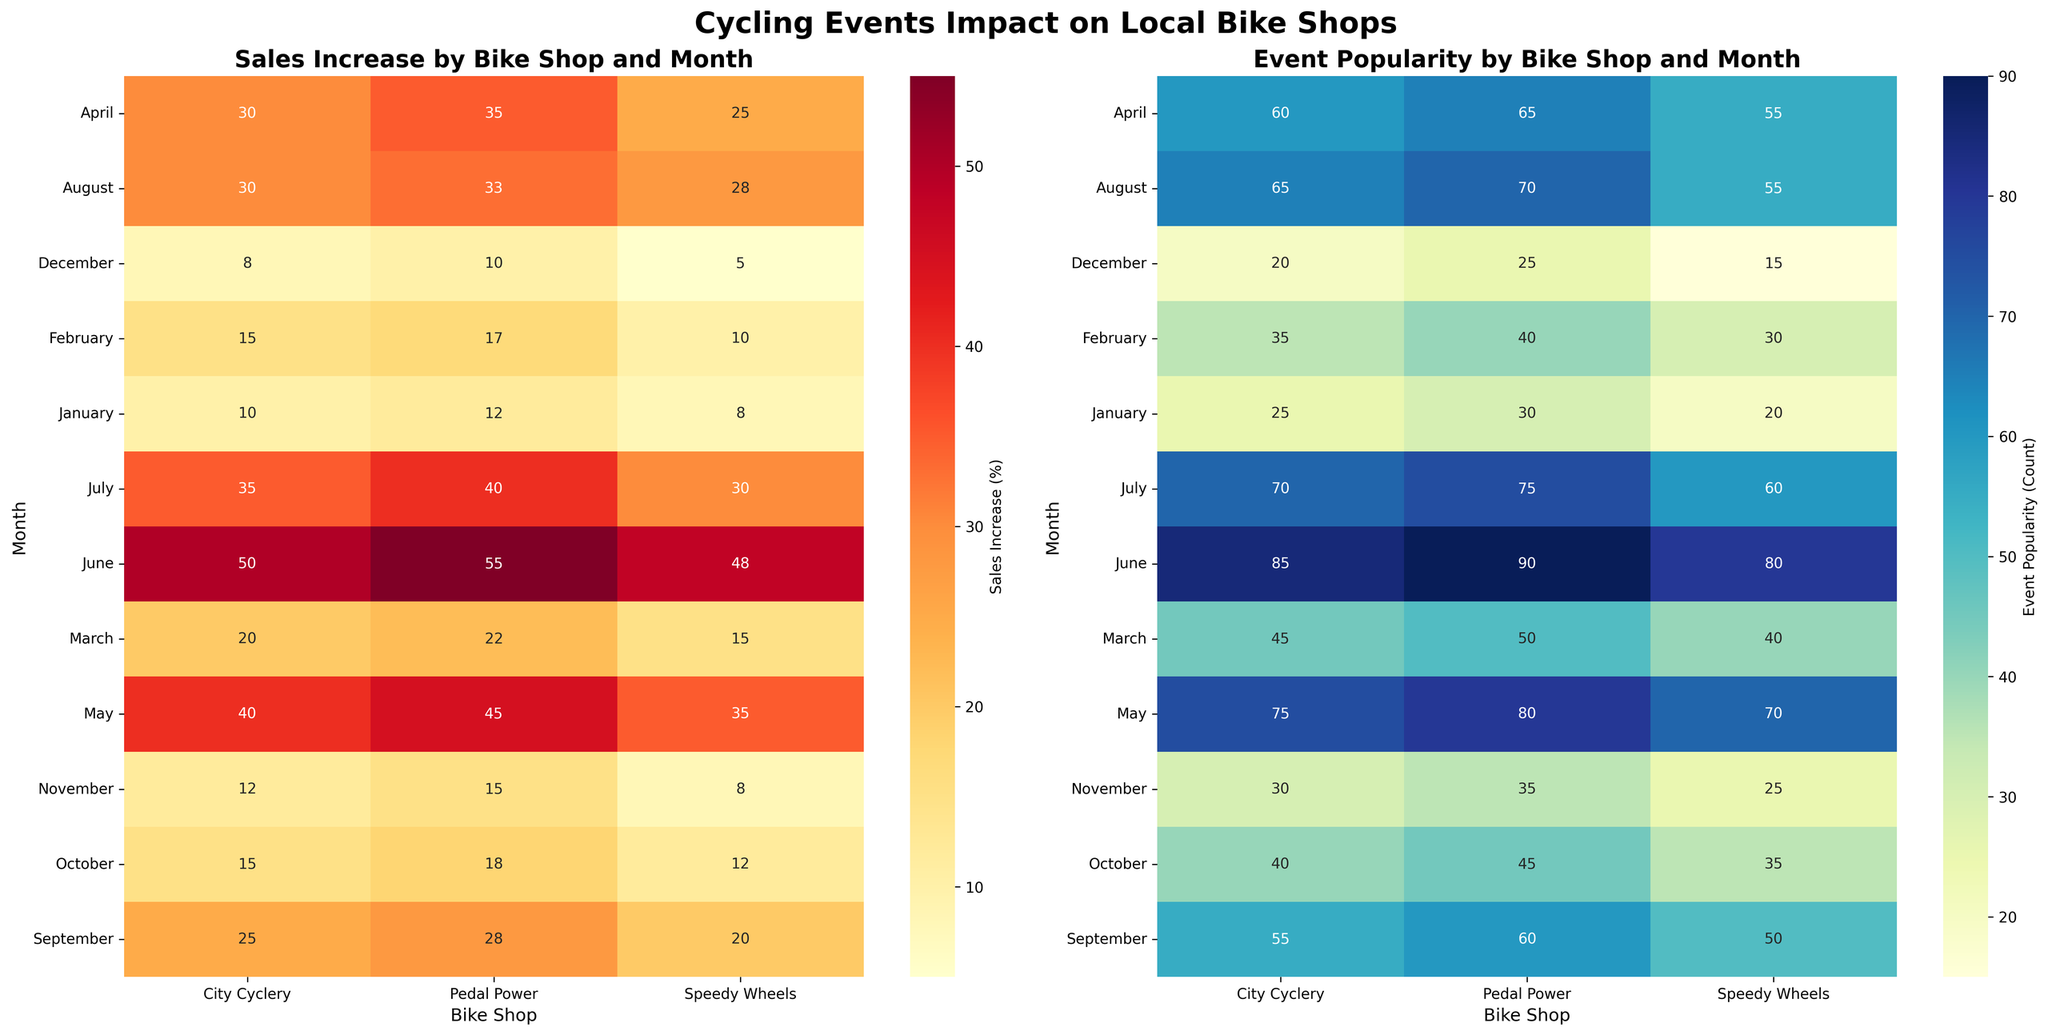Which month has the highest sales increase at Pedal Power? Looking at the "Sales Increase by Bike Shop and Month" heatmap, identify the highest sales increase for Pedal Power. The brightest color corresponds to the highest value which is 55% in June.
Answer: June Which bike shop experienced a 40% sales increase in May? On the "Sales Increase by Bike Shop and Month" heatmap, find the 40% sales increase in May. The darkest color in May corresponds to City Cyclery.
Answer: City Cyclery What is the average event popularity for Speedy Wheels across all months? In the "Event Popularity by Bike Shop and Month" heatmap, sum the popularity values for Speedy Wheels for each month (20 + 30 + 40 + 55 + 70 + 80 + 60 + 55 + 50 + 35 + 25 + 15) = 535. Then, divide by the number of months (12) to get the average: 535/12 ≈ 44.6.
Answer: 44.6 In which month does City Cyclery have the lowest sales increase? On the "Sales Increase by Bike Shop and Month" heatmap, find the month with the lowest percentage for City Cyclery. The lightest color corresponds to December with 8%.
Answer: December How does the event popularity trend compare between City Cyclery and Pedal Power across the year? Refer to the "Event Popularity by Bike Shop and Month" heatmap. Both bike shops show a trend where event popularity increases from January, peaks around May-June, and then gradually decreases towards December. Specifically, City Cyclery starts at 25 in January, peaks at 85 in June, and drops to 20 in December. Pedal Power starts at 30 in January, peaks at 90 in June, and drops to 25 in December.
Answer: Both shops follow a similar trend Which bike shop shows the most consistent sales increase over different months? On the "Sales Increase by Bike Shop and Month" heatmap, compare the variation in sales increases for all bike shops. Pedal Power and City Cyclery show a smooth increase, but Speedy Wheels has more fluctuations. Overall, City Cyclery's changes seem the least erratic.
Answer: City Cyclery Is there a month where all bike shops have nearly equal event popularity? Look at the "Event Popularity by Bike Shop and Month" heatmap and find if there's a month where the values for all three shops are close. In February, the popularity numbers are 35, 40, and 30, respectively, which are quite close compared to other months.
Answer: February 